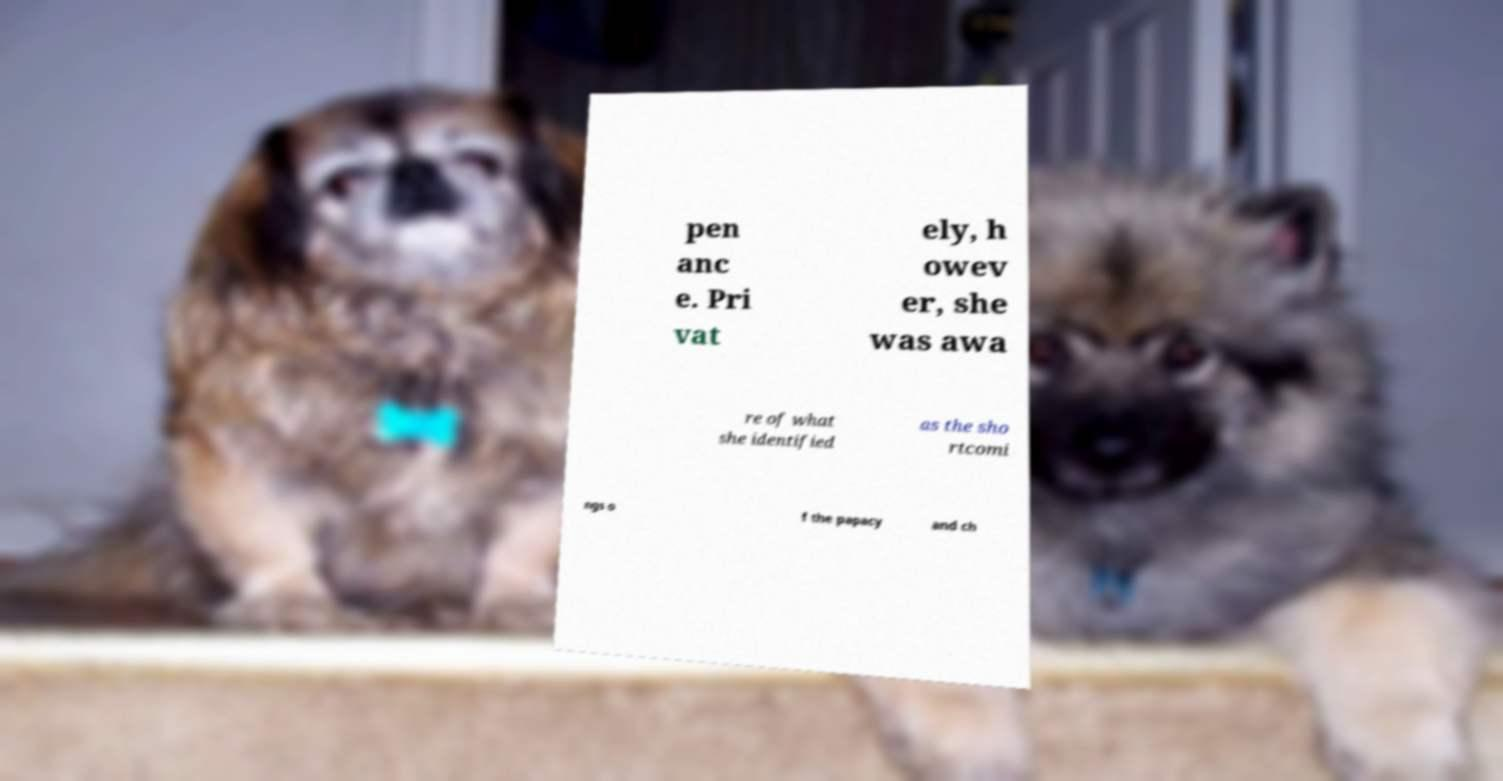There's text embedded in this image that I need extracted. Can you transcribe it verbatim? pen anc e. Pri vat ely, h owev er, she was awa re of what she identified as the sho rtcomi ngs o f the papacy and ch 